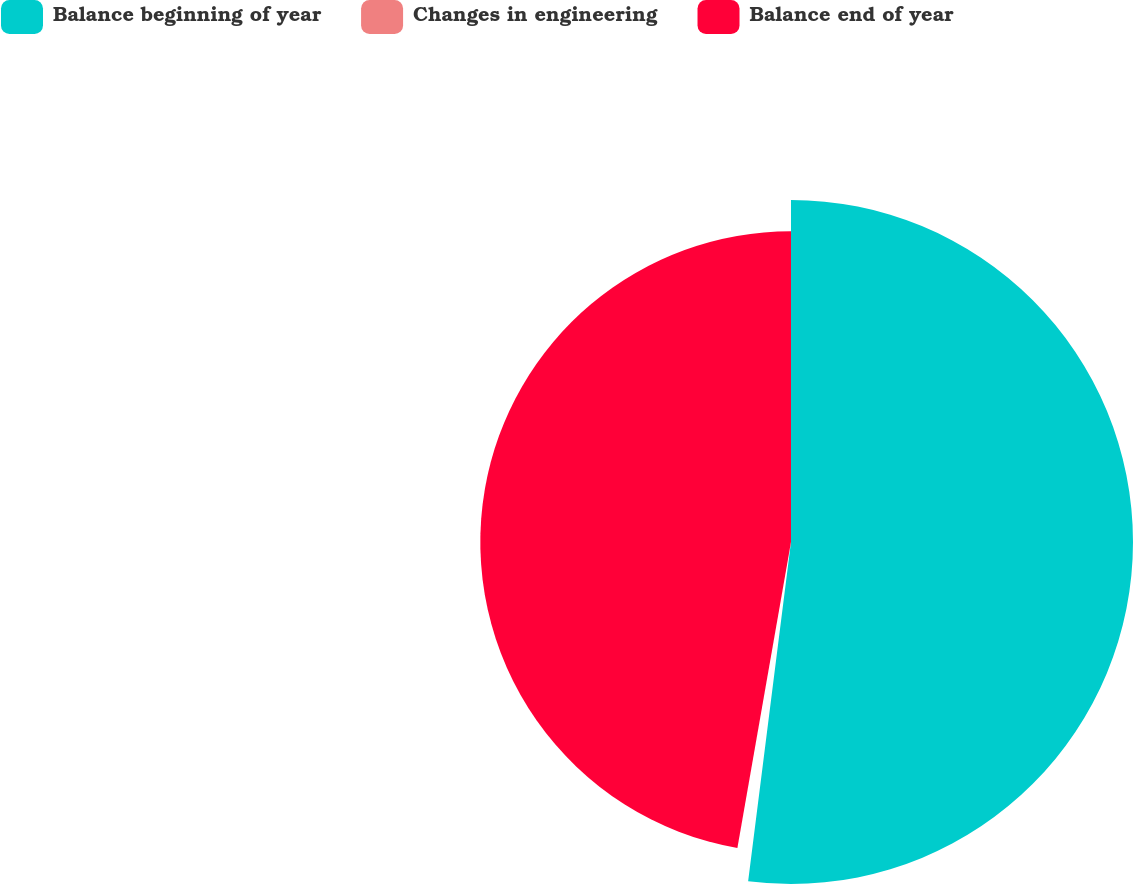<chart> <loc_0><loc_0><loc_500><loc_500><pie_chart><fcel>Balance beginning of year<fcel>Changes in engineering<fcel>Balance end of year<nl><fcel>52.0%<fcel>0.76%<fcel>47.24%<nl></chart> 